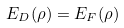<formula> <loc_0><loc_0><loc_500><loc_500>E _ { D } ( \rho ) = E _ { F } ( \rho )</formula> 